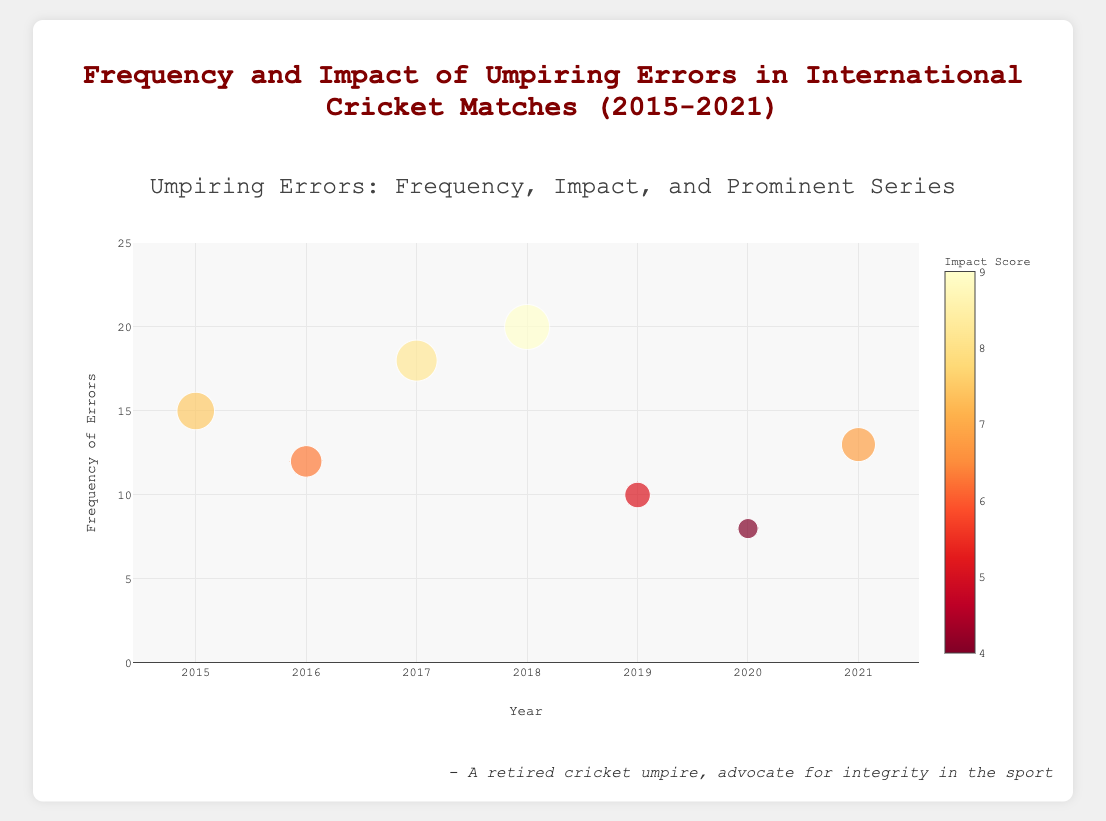What is the year with the highest frequency of umpiring errors? Locate the data point with the highest y-axis value (Frequency of Errors). The highest point is at 2018 with a frequency of 20 errors.
Answer: 2018 What was the prominent series in 2017? Hover over the data point for the year 2017 to read the text. The series mentioned is "Australia vs South Africa."
Answer: Australia vs South Africa Which year had the lowest impact score? Compare the impact scores (bubble sizes and colors). The smallest value corresponds to the year 2020, which has an impact score of 4.0.
Answer: 2020 How did the frequency of umpiring errors change from 2019 to 2020? Compare the frequency of errors between the two consecutive years. 2019 had 10 errors, while 2020 had 8 errors, indicating a decrease by 2 errors.
Answer: Decreased by 2 Between 2016 and 2021, which year had the highest impact score? Examine the size and color of the bubbles from 2016 to 2021. The year 2018 has the largest and darkest bubble, indicating the highest impact score of 9.0 during this period.
Answer: 2018 What is the average frequency of errors from 2015 to 2021? Sum the frequency of errors for all years (15 + 12 + 18 + 20 + 10 + 8 + 13 = 96) and divide by the number of years (7). Thus, the average is 96 / 7 ≈ 13.71.
Answer: 13.71 Which year had a higher impact score: 2017 or 2021? Compare the impact scores directly. 2017 has an impact score of 8.2, while 2021 has an impact score of 6.8. Thus, 2017 had a higher impact score.
Answer: 2017 In which year was the “Ashes” series prominent, and what was the frequency of errors that year? Hover over the data points to find the year with "Ashes 2015" in the text. The year is 2015 with a frequency of 15 errors.
Answer: 2015, 15 How did the impact score change from 2016 to 2017? Compare the impact scores for the two years. 2016 had a score of 6.3, while 2017 had a score of 8.2, showing an increase by 1.9.
Answer: Increased by 1.9 